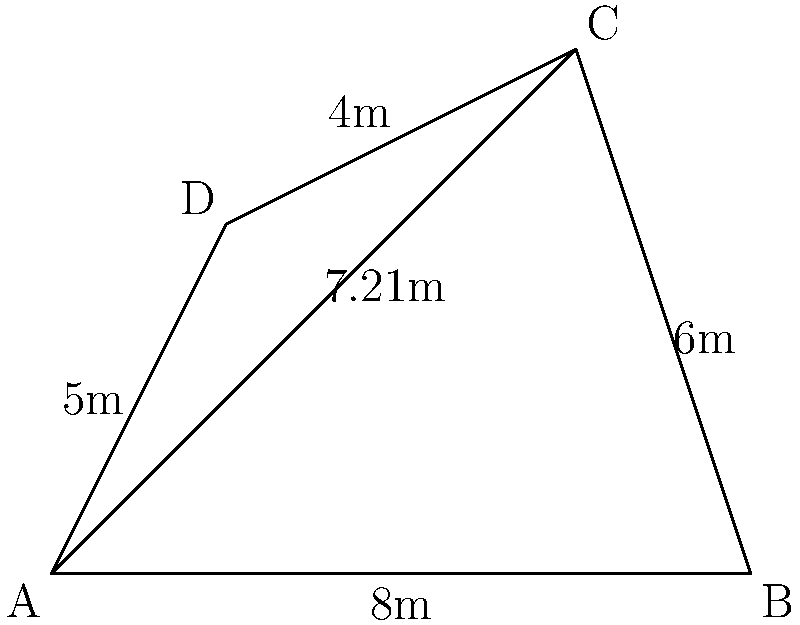At a crime scene, you've marked off an irregularly shaped area ABCD. The dimensions are as follows: AB = 8m, BC = 6m, CD = 4m, and DA = 5m. You've also measured the diagonal AC to be 7.21m. Calculate the total area of the crime scene to the nearest square meter. To solve this problem, we can use triangulation by dividing the irregular shape into two triangles: ABC and ACD. We'll then calculate the area of each triangle and sum them up.

Step 1: Calculate the area of triangle ABC using Heron's formula.
Let $s$ be the semi-perimeter of triangle ABC.
$s = (8 + 6 + 7.21) / 2 = 10.605$

Area of ABC = $\sqrt{s(s-a)(s-b)(s-c)}$
             = $\sqrt{10.605(10.605-8)(10.605-6)(10.605-7.21)}$
             = $\sqrt{10.605 * 2.605 * 4.605 * 3.395}$
             = 23.78 m²

Step 2: Calculate the area of triangle ACD using Heron's formula.
Let $s$ be the semi-perimeter of triangle ACD.
$s = (7.21 + 4 + 5) / 2 = 8.105$

Area of ACD = $\sqrt{s(s-a)(s-b)(s-c)}$
             = $\sqrt{8.105(8.105-7.21)(8.105-4)(8.105-5)}$
             = $\sqrt{8.105 * 0.895 * 4.105 * 3.105}$
             = 9.22 m²

Step 3: Calculate the total area by summing the areas of the two triangles.
Total Area = Area of ABC + Area of ACD
           = 23.78 + 9.22
           = 33 m² (rounded to the nearest square meter)
Answer: 33 m² 